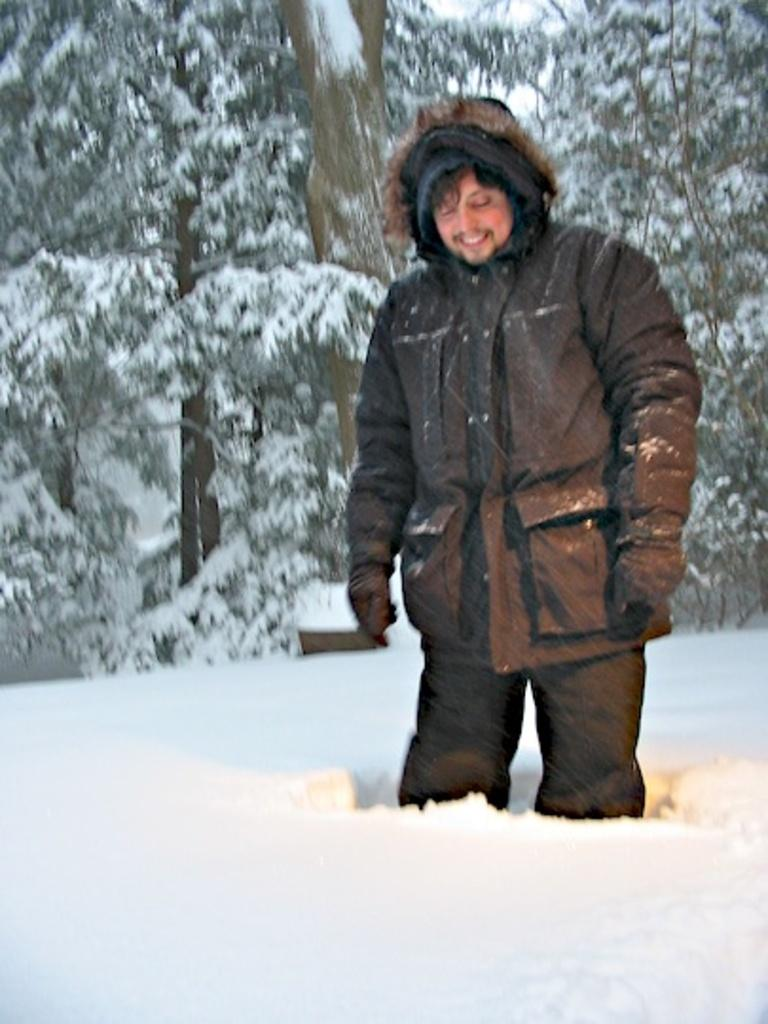Who or what is the main subject in the front of the image? There is a person in the front of the image. What type of environment is the person in? The person is in a snowy environment. What can be seen in the background of the image? There are trees in the background of the image. How many lizards can be seen basking in the snow in the image? There are no lizards present in the image; it features a person in a snowy environment with trees in the background. What type of stew is being prepared in the image? There is no stew or cooking activity depicted in the image. 